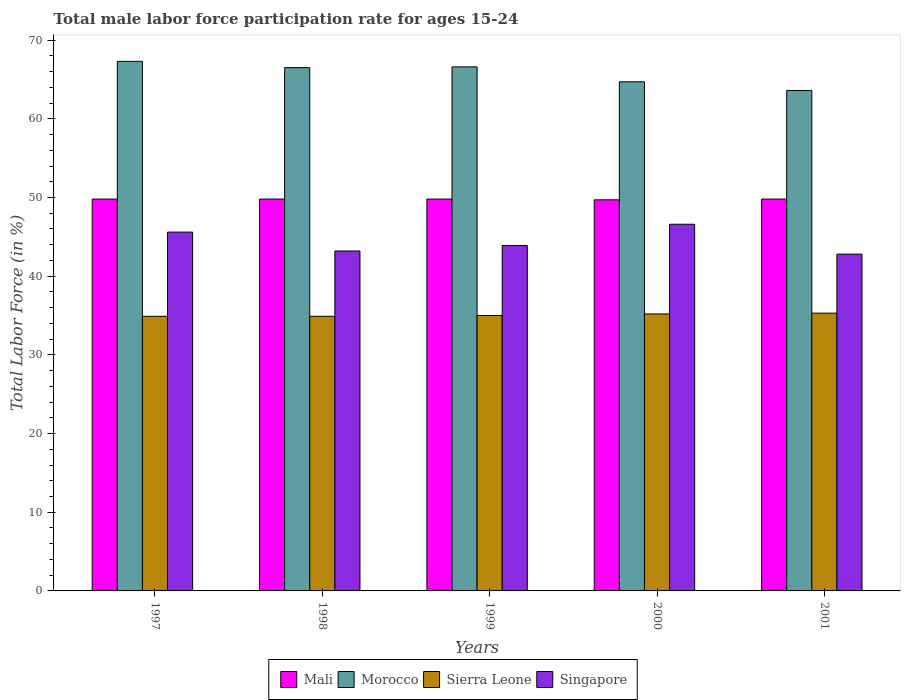Are the number of bars per tick equal to the number of legend labels?
Your answer should be very brief. Yes. What is the label of the 3rd group of bars from the left?
Offer a terse response. 1999. What is the male labor force participation rate in Singapore in 2001?
Your response must be concise. 42.8. Across all years, what is the maximum male labor force participation rate in Singapore?
Your answer should be very brief. 46.6. Across all years, what is the minimum male labor force participation rate in Singapore?
Provide a short and direct response. 42.8. In which year was the male labor force participation rate in Sierra Leone maximum?
Your response must be concise. 2001. What is the total male labor force participation rate in Mali in the graph?
Provide a short and direct response. 248.9. What is the difference between the male labor force participation rate in Singapore in 2001 and the male labor force participation rate in Mali in 1999?
Your response must be concise. -7. What is the average male labor force participation rate in Mali per year?
Make the answer very short. 49.78. In the year 2001, what is the difference between the male labor force participation rate in Morocco and male labor force participation rate in Singapore?
Offer a very short reply. 20.8. What is the ratio of the male labor force participation rate in Singapore in 1999 to that in 2001?
Provide a succinct answer. 1.03. Is the male labor force participation rate in Sierra Leone in 1997 less than that in 2000?
Offer a very short reply. Yes. What is the difference between the highest and the lowest male labor force participation rate in Singapore?
Give a very brief answer. 3.8. In how many years, is the male labor force participation rate in Morocco greater than the average male labor force participation rate in Morocco taken over all years?
Your response must be concise. 3. Is it the case that in every year, the sum of the male labor force participation rate in Singapore and male labor force participation rate in Morocco is greater than the sum of male labor force participation rate in Sierra Leone and male labor force participation rate in Mali?
Give a very brief answer. Yes. What does the 1st bar from the left in 2001 represents?
Ensure brevity in your answer.  Mali. What does the 3rd bar from the right in 2001 represents?
Ensure brevity in your answer.  Morocco. Are all the bars in the graph horizontal?
Your response must be concise. No. What is the difference between two consecutive major ticks on the Y-axis?
Make the answer very short. 10. Does the graph contain any zero values?
Your response must be concise. No. Does the graph contain grids?
Ensure brevity in your answer.  No. How many legend labels are there?
Offer a very short reply. 4. What is the title of the graph?
Make the answer very short. Total male labor force participation rate for ages 15-24. What is the label or title of the X-axis?
Keep it short and to the point. Years. What is the Total Labor Force (in %) of Mali in 1997?
Give a very brief answer. 49.8. What is the Total Labor Force (in %) of Morocco in 1997?
Ensure brevity in your answer.  67.3. What is the Total Labor Force (in %) in Sierra Leone in 1997?
Offer a terse response. 34.9. What is the Total Labor Force (in %) in Singapore in 1997?
Keep it short and to the point. 45.6. What is the Total Labor Force (in %) of Mali in 1998?
Provide a short and direct response. 49.8. What is the Total Labor Force (in %) in Morocco in 1998?
Ensure brevity in your answer.  66.5. What is the Total Labor Force (in %) in Sierra Leone in 1998?
Your answer should be very brief. 34.9. What is the Total Labor Force (in %) in Singapore in 1998?
Make the answer very short. 43.2. What is the Total Labor Force (in %) of Mali in 1999?
Your answer should be compact. 49.8. What is the Total Labor Force (in %) in Morocco in 1999?
Your answer should be compact. 66.6. What is the Total Labor Force (in %) of Singapore in 1999?
Give a very brief answer. 43.9. What is the Total Labor Force (in %) in Mali in 2000?
Offer a terse response. 49.7. What is the Total Labor Force (in %) of Morocco in 2000?
Offer a terse response. 64.7. What is the Total Labor Force (in %) in Sierra Leone in 2000?
Give a very brief answer. 35.2. What is the Total Labor Force (in %) in Singapore in 2000?
Provide a short and direct response. 46.6. What is the Total Labor Force (in %) in Mali in 2001?
Offer a very short reply. 49.8. What is the Total Labor Force (in %) in Morocco in 2001?
Ensure brevity in your answer.  63.6. What is the Total Labor Force (in %) in Sierra Leone in 2001?
Offer a terse response. 35.3. What is the Total Labor Force (in %) of Singapore in 2001?
Make the answer very short. 42.8. Across all years, what is the maximum Total Labor Force (in %) of Mali?
Your answer should be very brief. 49.8. Across all years, what is the maximum Total Labor Force (in %) in Morocco?
Provide a succinct answer. 67.3. Across all years, what is the maximum Total Labor Force (in %) of Sierra Leone?
Make the answer very short. 35.3. Across all years, what is the maximum Total Labor Force (in %) of Singapore?
Provide a succinct answer. 46.6. Across all years, what is the minimum Total Labor Force (in %) of Mali?
Ensure brevity in your answer.  49.7. Across all years, what is the minimum Total Labor Force (in %) of Morocco?
Offer a terse response. 63.6. Across all years, what is the minimum Total Labor Force (in %) of Sierra Leone?
Offer a terse response. 34.9. Across all years, what is the minimum Total Labor Force (in %) in Singapore?
Keep it short and to the point. 42.8. What is the total Total Labor Force (in %) of Mali in the graph?
Give a very brief answer. 248.9. What is the total Total Labor Force (in %) in Morocco in the graph?
Provide a succinct answer. 328.7. What is the total Total Labor Force (in %) of Sierra Leone in the graph?
Provide a succinct answer. 175.3. What is the total Total Labor Force (in %) in Singapore in the graph?
Offer a very short reply. 222.1. What is the difference between the Total Labor Force (in %) in Sierra Leone in 1997 and that in 1998?
Provide a short and direct response. 0. What is the difference between the Total Labor Force (in %) in Mali in 1997 and that in 1999?
Ensure brevity in your answer.  0. What is the difference between the Total Labor Force (in %) of Mali in 1997 and that in 2000?
Your answer should be compact. 0.1. What is the difference between the Total Labor Force (in %) in Sierra Leone in 1997 and that in 2000?
Give a very brief answer. -0.3. What is the difference between the Total Labor Force (in %) of Singapore in 1997 and that in 2000?
Give a very brief answer. -1. What is the difference between the Total Labor Force (in %) in Mali in 1997 and that in 2001?
Offer a very short reply. 0. What is the difference between the Total Labor Force (in %) of Morocco in 1997 and that in 2001?
Your answer should be very brief. 3.7. What is the difference between the Total Labor Force (in %) of Sierra Leone in 1997 and that in 2001?
Your answer should be compact. -0.4. What is the difference between the Total Labor Force (in %) in Singapore in 1997 and that in 2001?
Provide a succinct answer. 2.8. What is the difference between the Total Labor Force (in %) of Singapore in 1998 and that in 1999?
Provide a succinct answer. -0.7. What is the difference between the Total Labor Force (in %) of Mali in 1998 and that in 2000?
Your response must be concise. 0.1. What is the difference between the Total Labor Force (in %) in Morocco in 1998 and that in 2000?
Keep it short and to the point. 1.8. What is the difference between the Total Labor Force (in %) in Sierra Leone in 1998 and that in 2000?
Offer a very short reply. -0.3. What is the difference between the Total Labor Force (in %) of Mali in 1998 and that in 2001?
Your answer should be compact. 0. What is the difference between the Total Labor Force (in %) of Morocco in 1998 and that in 2001?
Provide a succinct answer. 2.9. What is the difference between the Total Labor Force (in %) in Mali in 1999 and that in 2000?
Make the answer very short. 0.1. What is the difference between the Total Labor Force (in %) in Mali in 1999 and that in 2001?
Make the answer very short. 0. What is the difference between the Total Labor Force (in %) of Morocco in 1999 and that in 2001?
Offer a terse response. 3. What is the difference between the Total Labor Force (in %) of Morocco in 2000 and that in 2001?
Offer a terse response. 1.1. What is the difference between the Total Labor Force (in %) of Mali in 1997 and the Total Labor Force (in %) of Morocco in 1998?
Your answer should be very brief. -16.7. What is the difference between the Total Labor Force (in %) in Mali in 1997 and the Total Labor Force (in %) in Sierra Leone in 1998?
Ensure brevity in your answer.  14.9. What is the difference between the Total Labor Force (in %) of Morocco in 1997 and the Total Labor Force (in %) of Sierra Leone in 1998?
Make the answer very short. 32.4. What is the difference between the Total Labor Force (in %) of Morocco in 1997 and the Total Labor Force (in %) of Singapore in 1998?
Keep it short and to the point. 24.1. What is the difference between the Total Labor Force (in %) of Mali in 1997 and the Total Labor Force (in %) of Morocco in 1999?
Provide a succinct answer. -16.8. What is the difference between the Total Labor Force (in %) in Mali in 1997 and the Total Labor Force (in %) in Sierra Leone in 1999?
Your answer should be very brief. 14.8. What is the difference between the Total Labor Force (in %) in Morocco in 1997 and the Total Labor Force (in %) in Sierra Leone in 1999?
Make the answer very short. 32.3. What is the difference between the Total Labor Force (in %) in Morocco in 1997 and the Total Labor Force (in %) in Singapore in 1999?
Provide a succinct answer. 23.4. What is the difference between the Total Labor Force (in %) in Mali in 1997 and the Total Labor Force (in %) in Morocco in 2000?
Your answer should be very brief. -14.9. What is the difference between the Total Labor Force (in %) in Mali in 1997 and the Total Labor Force (in %) in Sierra Leone in 2000?
Your answer should be compact. 14.6. What is the difference between the Total Labor Force (in %) of Mali in 1997 and the Total Labor Force (in %) of Singapore in 2000?
Provide a succinct answer. 3.2. What is the difference between the Total Labor Force (in %) of Morocco in 1997 and the Total Labor Force (in %) of Sierra Leone in 2000?
Ensure brevity in your answer.  32.1. What is the difference between the Total Labor Force (in %) in Morocco in 1997 and the Total Labor Force (in %) in Singapore in 2000?
Keep it short and to the point. 20.7. What is the difference between the Total Labor Force (in %) of Sierra Leone in 1997 and the Total Labor Force (in %) of Singapore in 2000?
Your response must be concise. -11.7. What is the difference between the Total Labor Force (in %) in Mali in 1997 and the Total Labor Force (in %) in Sierra Leone in 2001?
Offer a terse response. 14.5. What is the difference between the Total Labor Force (in %) in Mali in 1997 and the Total Labor Force (in %) in Singapore in 2001?
Offer a terse response. 7. What is the difference between the Total Labor Force (in %) in Mali in 1998 and the Total Labor Force (in %) in Morocco in 1999?
Keep it short and to the point. -16.8. What is the difference between the Total Labor Force (in %) of Mali in 1998 and the Total Labor Force (in %) of Singapore in 1999?
Your answer should be compact. 5.9. What is the difference between the Total Labor Force (in %) in Morocco in 1998 and the Total Labor Force (in %) in Sierra Leone in 1999?
Give a very brief answer. 31.5. What is the difference between the Total Labor Force (in %) in Morocco in 1998 and the Total Labor Force (in %) in Singapore in 1999?
Keep it short and to the point. 22.6. What is the difference between the Total Labor Force (in %) in Sierra Leone in 1998 and the Total Labor Force (in %) in Singapore in 1999?
Your answer should be very brief. -9. What is the difference between the Total Labor Force (in %) in Mali in 1998 and the Total Labor Force (in %) in Morocco in 2000?
Your response must be concise. -14.9. What is the difference between the Total Labor Force (in %) of Morocco in 1998 and the Total Labor Force (in %) of Sierra Leone in 2000?
Offer a terse response. 31.3. What is the difference between the Total Labor Force (in %) of Mali in 1998 and the Total Labor Force (in %) of Sierra Leone in 2001?
Provide a succinct answer. 14.5. What is the difference between the Total Labor Force (in %) of Morocco in 1998 and the Total Labor Force (in %) of Sierra Leone in 2001?
Ensure brevity in your answer.  31.2. What is the difference between the Total Labor Force (in %) in Morocco in 1998 and the Total Labor Force (in %) in Singapore in 2001?
Provide a short and direct response. 23.7. What is the difference between the Total Labor Force (in %) of Sierra Leone in 1998 and the Total Labor Force (in %) of Singapore in 2001?
Make the answer very short. -7.9. What is the difference between the Total Labor Force (in %) in Mali in 1999 and the Total Labor Force (in %) in Morocco in 2000?
Keep it short and to the point. -14.9. What is the difference between the Total Labor Force (in %) of Mali in 1999 and the Total Labor Force (in %) of Sierra Leone in 2000?
Provide a succinct answer. 14.6. What is the difference between the Total Labor Force (in %) of Mali in 1999 and the Total Labor Force (in %) of Singapore in 2000?
Ensure brevity in your answer.  3.2. What is the difference between the Total Labor Force (in %) of Morocco in 1999 and the Total Labor Force (in %) of Sierra Leone in 2000?
Provide a short and direct response. 31.4. What is the difference between the Total Labor Force (in %) in Morocco in 1999 and the Total Labor Force (in %) in Singapore in 2000?
Your response must be concise. 20. What is the difference between the Total Labor Force (in %) of Mali in 1999 and the Total Labor Force (in %) of Singapore in 2001?
Give a very brief answer. 7. What is the difference between the Total Labor Force (in %) of Morocco in 1999 and the Total Labor Force (in %) of Sierra Leone in 2001?
Your response must be concise. 31.3. What is the difference between the Total Labor Force (in %) in Morocco in 1999 and the Total Labor Force (in %) in Singapore in 2001?
Offer a terse response. 23.8. What is the difference between the Total Labor Force (in %) in Sierra Leone in 1999 and the Total Labor Force (in %) in Singapore in 2001?
Provide a succinct answer. -7.8. What is the difference between the Total Labor Force (in %) in Mali in 2000 and the Total Labor Force (in %) in Sierra Leone in 2001?
Make the answer very short. 14.4. What is the difference between the Total Labor Force (in %) of Morocco in 2000 and the Total Labor Force (in %) of Sierra Leone in 2001?
Your answer should be compact. 29.4. What is the difference between the Total Labor Force (in %) in Morocco in 2000 and the Total Labor Force (in %) in Singapore in 2001?
Give a very brief answer. 21.9. What is the difference between the Total Labor Force (in %) of Sierra Leone in 2000 and the Total Labor Force (in %) of Singapore in 2001?
Make the answer very short. -7.6. What is the average Total Labor Force (in %) of Mali per year?
Keep it short and to the point. 49.78. What is the average Total Labor Force (in %) in Morocco per year?
Your answer should be very brief. 65.74. What is the average Total Labor Force (in %) of Sierra Leone per year?
Provide a succinct answer. 35.06. What is the average Total Labor Force (in %) in Singapore per year?
Provide a succinct answer. 44.42. In the year 1997, what is the difference between the Total Labor Force (in %) in Mali and Total Labor Force (in %) in Morocco?
Provide a short and direct response. -17.5. In the year 1997, what is the difference between the Total Labor Force (in %) in Morocco and Total Labor Force (in %) in Sierra Leone?
Give a very brief answer. 32.4. In the year 1997, what is the difference between the Total Labor Force (in %) in Morocco and Total Labor Force (in %) in Singapore?
Keep it short and to the point. 21.7. In the year 1998, what is the difference between the Total Labor Force (in %) in Mali and Total Labor Force (in %) in Morocco?
Your response must be concise. -16.7. In the year 1998, what is the difference between the Total Labor Force (in %) of Morocco and Total Labor Force (in %) of Sierra Leone?
Provide a short and direct response. 31.6. In the year 1998, what is the difference between the Total Labor Force (in %) of Morocco and Total Labor Force (in %) of Singapore?
Provide a short and direct response. 23.3. In the year 1999, what is the difference between the Total Labor Force (in %) in Mali and Total Labor Force (in %) in Morocco?
Offer a very short reply. -16.8. In the year 1999, what is the difference between the Total Labor Force (in %) in Mali and Total Labor Force (in %) in Sierra Leone?
Ensure brevity in your answer.  14.8. In the year 1999, what is the difference between the Total Labor Force (in %) in Morocco and Total Labor Force (in %) in Sierra Leone?
Provide a short and direct response. 31.6. In the year 1999, what is the difference between the Total Labor Force (in %) of Morocco and Total Labor Force (in %) of Singapore?
Provide a succinct answer. 22.7. In the year 2000, what is the difference between the Total Labor Force (in %) in Mali and Total Labor Force (in %) in Morocco?
Keep it short and to the point. -15. In the year 2000, what is the difference between the Total Labor Force (in %) of Morocco and Total Labor Force (in %) of Sierra Leone?
Your answer should be compact. 29.5. In the year 2000, what is the difference between the Total Labor Force (in %) of Sierra Leone and Total Labor Force (in %) of Singapore?
Offer a terse response. -11.4. In the year 2001, what is the difference between the Total Labor Force (in %) in Mali and Total Labor Force (in %) in Morocco?
Your answer should be very brief. -13.8. In the year 2001, what is the difference between the Total Labor Force (in %) of Mali and Total Labor Force (in %) of Sierra Leone?
Your answer should be very brief. 14.5. In the year 2001, what is the difference between the Total Labor Force (in %) of Morocco and Total Labor Force (in %) of Sierra Leone?
Offer a terse response. 28.3. In the year 2001, what is the difference between the Total Labor Force (in %) of Morocco and Total Labor Force (in %) of Singapore?
Make the answer very short. 20.8. What is the ratio of the Total Labor Force (in %) in Morocco in 1997 to that in 1998?
Your answer should be very brief. 1.01. What is the ratio of the Total Labor Force (in %) of Singapore in 1997 to that in 1998?
Your answer should be compact. 1.06. What is the ratio of the Total Labor Force (in %) of Mali in 1997 to that in 1999?
Provide a short and direct response. 1. What is the ratio of the Total Labor Force (in %) in Morocco in 1997 to that in 1999?
Keep it short and to the point. 1.01. What is the ratio of the Total Labor Force (in %) in Sierra Leone in 1997 to that in 1999?
Offer a terse response. 1. What is the ratio of the Total Labor Force (in %) of Singapore in 1997 to that in 1999?
Offer a terse response. 1.04. What is the ratio of the Total Labor Force (in %) of Mali in 1997 to that in 2000?
Ensure brevity in your answer.  1. What is the ratio of the Total Labor Force (in %) of Morocco in 1997 to that in 2000?
Provide a short and direct response. 1.04. What is the ratio of the Total Labor Force (in %) in Sierra Leone in 1997 to that in 2000?
Your answer should be compact. 0.99. What is the ratio of the Total Labor Force (in %) of Singapore in 1997 to that in 2000?
Provide a short and direct response. 0.98. What is the ratio of the Total Labor Force (in %) of Morocco in 1997 to that in 2001?
Offer a terse response. 1.06. What is the ratio of the Total Labor Force (in %) in Sierra Leone in 1997 to that in 2001?
Offer a very short reply. 0.99. What is the ratio of the Total Labor Force (in %) of Singapore in 1997 to that in 2001?
Make the answer very short. 1.07. What is the ratio of the Total Labor Force (in %) of Mali in 1998 to that in 1999?
Give a very brief answer. 1. What is the ratio of the Total Labor Force (in %) in Singapore in 1998 to that in 1999?
Ensure brevity in your answer.  0.98. What is the ratio of the Total Labor Force (in %) in Mali in 1998 to that in 2000?
Give a very brief answer. 1. What is the ratio of the Total Labor Force (in %) of Morocco in 1998 to that in 2000?
Your response must be concise. 1.03. What is the ratio of the Total Labor Force (in %) of Sierra Leone in 1998 to that in 2000?
Give a very brief answer. 0.99. What is the ratio of the Total Labor Force (in %) in Singapore in 1998 to that in 2000?
Offer a very short reply. 0.93. What is the ratio of the Total Labor Force (in %) in Morocco in 1998 to that in 2001?
Your answer should be compact. 1.05. What is the ratio of the Total Labor Force (in %) of Sierra Leone in 1998 to that in 2001?
Your answer should be very brief. 0.99. What is the ratio of the Total Labor Force (in %) in Singapore in 1998 to that in 2001?
Offer a terse response. 1.01. What is the ratio of the Total Labor Force (in %) of Morocco in 1999 to that in 2000?
Provide a short and direct response. 1.03. What is the ratio of the Total Labor Force (in %) in Sierra Leone in 1999 to that in 2000?
Offer a very short reply. 0.99. What is the ratio of the Total Labor Force (in %) of Singapore in 1999 to that in 2000?
Make the answer very short. 0.94. What is the ratio of the Total Labor Force (in %) in Mali in 1999 to that in 2001?
Your answer should be compact. 1. What is the ratio of the Total Labor Force (in %) in Morocco in 1999 to that in 2001?
Offer a very short reply. 1.05. What is the ratio of the Total Labor Force (in %) in Singapore in 1999 to that in 2001?
Keep it short and to the point. 1.03. What is the ratio of the Total Labor Force (in %) of Mali in 2000 to that in 2001?
Make the answer very short. 1. What is the ratio of the Total Labor Force (in %) of Morocco in 2000 to that in 2001?
Provide a succinct answer. 1.02. What is the ratio of the Total Labor Force (in %) of Singapore in 2000 to that in 2001?
Offer a very short reply. 1.09. What is the difference between the highest and the second highest Total Labor Force (in %) in Mali?
Keep it short and to the point. 0. What is the difference between the highest and the second highest Total Labor Force (in %) of Morocco?
Your response must be concise. 0.7. What is the difference between the highest and the second highest Total Labor Force (in %) of Sierra Leone?
Ensure brevity in your answer.  0.1. What is the difference between the highest and the lowest Total Labor Force (in %) in Mali?
Your response must be concise. 0.1. What is the difference between the highest and the lowest Total Labor Force (in %) of Morocco?
Give a very brief answer. 3.7. What is the difference between the highest and the lowest Total Labor Force (in %) of Sierra Leone?
Your answer should be compact. 0.4. What is the difference between the highest and the lowest Total Labor Force (in %) in Singapore?
Offer a terse response. 3.8. 